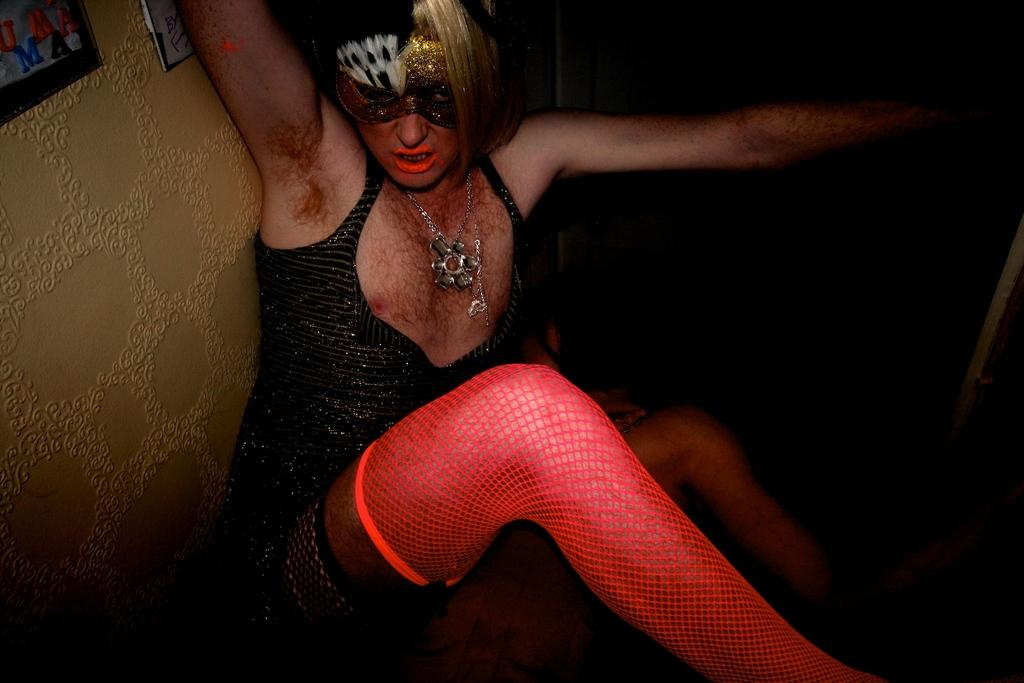Who or what is present in the image? There is a person in the image. What is the person wearing on their face? The person is wearing a black and gold mask. What can be seen in the background of the image? There is a wall in the image. What is attached to the wall? Frames are attached to the wall. How many legs does the horse have in the image? There is no horse present in the image. What type of table is visible in the image? There is no table present in the image. 